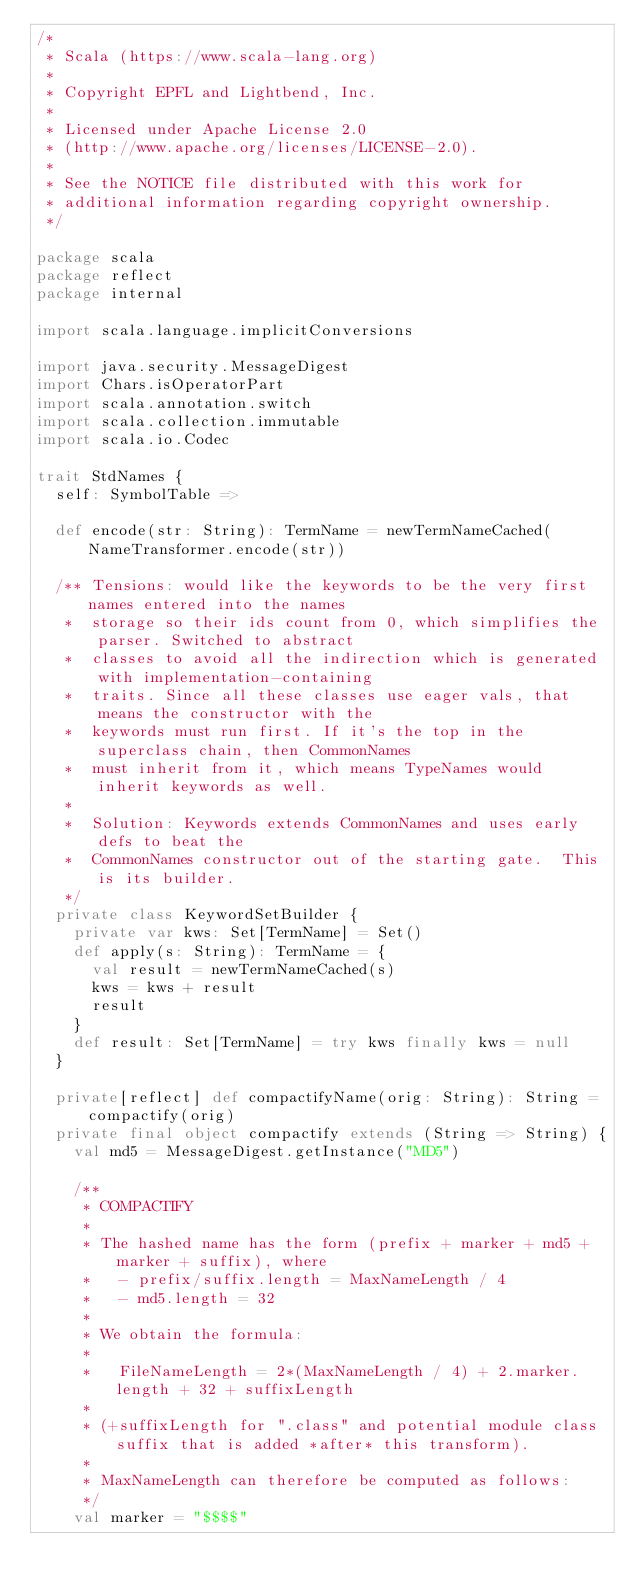<code> <loc_0><loc_0><loc_500><loc_500><_Scala_>/*
 * Scala (https://www.scala-lang.org)
 *
 * Copyright EPFL and Lightbend, Inc.
 *
 * Licensed under Apache License 2.0
 * (http://www.apache.org/licenses/LICENSE-2.0).
 *
 * See the NOTICE file distributed with this work for
 * additional information regarding copyright ownership.
 */

package scala
package reflect
package internal

import scala.language.implicitConversions

import java.security.MessageDigest
import Chars.isOperatorPart
import scala.annotation.switch
import scala.collection.immutable
import scala.io.Codec

trait StdNames {
  self: SymbolTable =>

  def encode(str: String): TermName = newTermNameCached(NameTransformer.encode(str))

  /** Tensions: would like the keywords to be the very first names entered into the names
   *  storage so their ids count from 0, which simplifies the parser. Switched to abstract
   *  classes to avoid all the indirection which is generated with implementation-containing
   *  traits. Since all these classes use eager vals, that means the constructor with the
   *  keywords must run first. If it's the top in the superclass chain, then CommonNames
   *  must inherit from it, which means TypeNames would inherit keywords as well.
   *
   *  Solution: Keywords extends CommonNames and uses early defs to beat the
   *  CommonNames constructor out of the starting gate.  This is its builder.
   */
  private class KeywordSetBuilder {
    private var kws: Set[TermName] = Set()
    def apply(s: String): TermName = {
      val result = newTermNameCached(s)
      kws = kws + result
      result
    }
    def result: Set[TermName] = try kws finally kws = null
  }

  private[reflect] def compactifyName(orig: String): String = compactify(orig)
  private final object compactify extends (String => String) {
    val md5 = MessageDigest.getInstance("MD5")

    /**
     * COMPACTIFY
     *
     * The hashed name has the form (prefix + marker + md5 + marker + suffix), where
     *   - prefix/suffix.length = MaxNameLength / 4
     *   - md5.length = 32
     *
     * We obtain the formula:
     *
     *   FileNameLength = 2*(MaxNameLength / 4) + 2.marker.length + 32 + suffixLength
     *
     * (+suffixLength for ".class" and potential module class suffix that is added *after* this transform).
     *
     * MaxNameLength can therefore be computed as follows:
     */
    val marker = "$$$$"</code> 